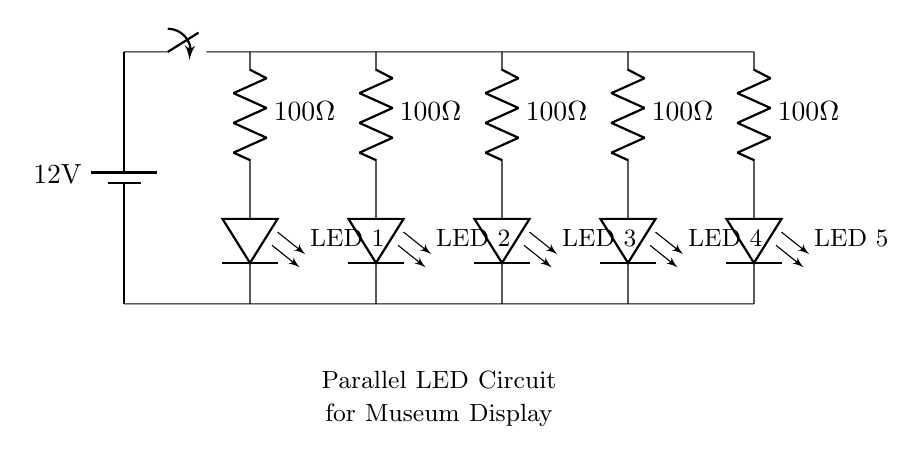What is the voltage of the battery? The voltage of the battery is specified in the circuit as 12 volts, which is indicated by the battery symbol with the label.
Answer: 12 volts What kind of circuit is this? This circuit is a parallel circuit, as evidenced by multiple branches connecting the LEDs and resistors independently to the same voltage source.
Answer: Parallel circuit How many LED lights are present in the circuit? There are five LED lights included in the circuit, as shown by the five LED symbols labeled as LED 1 through LED 5.
Answer: Five What is the resistance value for each resistor in the circuit? Each resistor is labeled with a value of 100 ohms, which can be seen next to each resistor symbol in the diagram.
Answer: 100 ohms What is the total current flowing if each LED draws 20 milliamps? Since it is a parallel circuit and each LED draws 20 milliamps, the total current can be calculated by multiplying the number of LEDs by the current per LED, resulting in 100 milliamps.
Answer: 100 milliamps How are the LEDs connected within the circuit? The LEDs are connected in parallel, which means each LED has its own branch connected directly to the common voltage supply, allowing them to operate independently of one another.
Answer: In parallel What would happen if one LED fails in this circuit? If one LED fails, the other LEDs would continue to operate, as they are individually connected to the power supply, characteristic of a parallel circuit.
Answer: Others continue to operate 